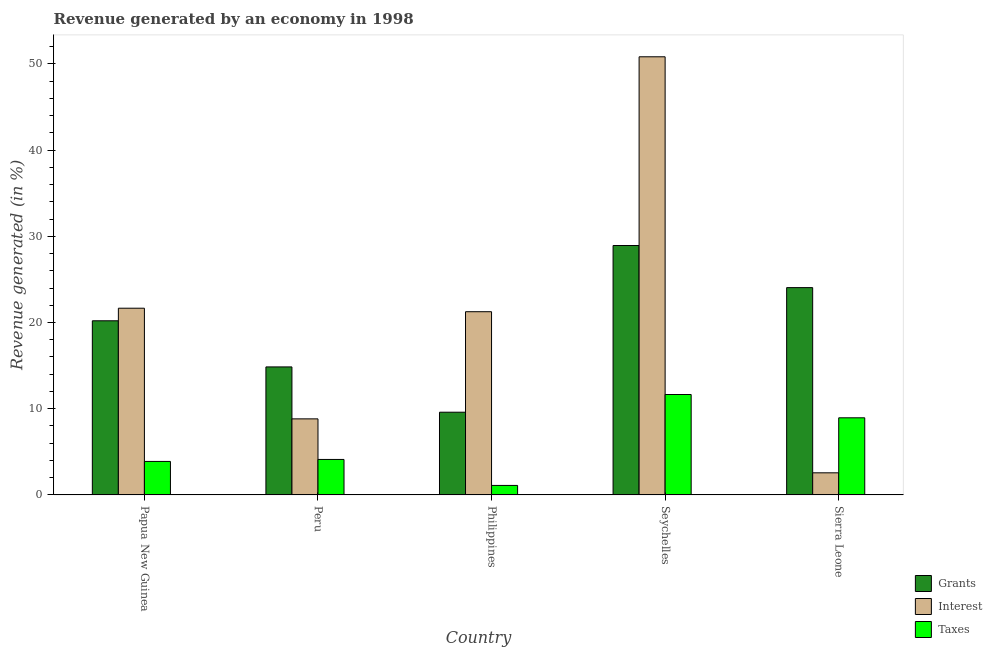How many different coloured bars are there?
Provide a short and direct response. 3. How many bars are there on the 1st tick from the right?
Provide a short and direct response. 3. What is the label of the 3rd group of bars from the left?
Provide a succinct answer. Philippines. What is the percentage of revenue generated by interest in Papua New Guinea?
Keep it short and to the point. 21.66. Across all countries, what is the maximum percentage of revenue generated by grants?
Offer a terse response. 28.93. Across all countries, what is the minimum percentage of revenue generated by taxes?
Your answer should be very brief. 1.1. In which country was the percentage of revenue generated by grants maximum?
Offer a terse response. Seychelles. What is the total percentage of revenue generated by taxes in the graph?
Offer a terse response. 29.7. What is the difference between the percentage of revenue generated by interest in Papua New Guinea and that in Seychelles?
Keep it short and to the point. -29.16. What is the difference between the percentage of revenue generated by interest in Peru and the percentage of revenue generated by grants in Philippines?
Offer a terse response. -0.77. What is the average percentage of revenue generated by interest per country?
Make the answer very short. 21.02. What is the difference between the percentage of revenue generated by interest and percentage of revenue generated by grants in Philippines?
Your answer should be very brief. 11.66. What is the ratio of the percentage of revenue generated by taxes in Philippines to that in Seychelles?
Your response must be concise. 0.09. What is the difference between the highest and the second highest percentage of revenue generated by grants?
Your response must be concise. 4.88. What is the difference between the highest and the lowest percentage of revenue generated by grants?
Provide a succinct answer. 19.33. What does the 3rd bar from the left in Seychelles represents?
Offer a very short reply. Taxes. What does the 3rd bar from the right in Seychelles represents?
Offer a very short reply. Grants. How many bars are there?
Make the answer very short. 15. How many countries are there in the graph?
Offer a terse response. 5. Does the graph contain any zero values?
Give a very brief answer. No. Does the graph contain grids?
Give a very brief answer. No. How many legend labels are there?
Ensure brevity in your answer.  3. What is the title of the graph?
Your answer should be compact. Revenue generated by an economy in 1998. Does "Ages 50+" appear as one of the legend labels in the graph?
Ensure brevity in your answer.  No. What is the label or title of the X-axis?
Offer a very short reply. Country. What is the label or title of the Y-axis?
Ensure brevity in your answer.  Revenue generated (in %). What is the Revenue generated (in %) of Grants in Papua New Guinea?
Provide a short and direct response. 20.2. What is the Revenue generated (in %) in Interest in Papua New Guinea?
Your response must be concise. 21.66. What is the Revenue generated (in %) of Taxes in Papua New Guinea?
Your answer should be compact. 3.89. What is the Revenue generated (in %) in Grants in Peru?
Offer a terse response. 14.85. What is the Revenue generated (in %) in Interest in Peru?
Make the answer very short. 8.82. What is the Revenue generated (in %) of Taxes in Peru?
Your response must be concise. 4.12. What is the Revenue generated (in %) of Grants in Philippines?
Give a very brief answer. 9.59. What is the Revenue generated (in %) of Interest in Philippines?
Give a very brief answer. 21.25. What is the Revenue generated (in %) of Taxes in Philippines?
Offer a terse response. 1.1. What is the Revenue generated (in %) in Grants in Seychelles?
Offer a terse response. 28.93. What is the Revenue generated (in %) in Interest in Seychelles?
Your answer should be compact. 50.82. What is the Revenue generated (in %) in Taxes in Seychelles?
Ensure brevity in your answer.  11.65. What is the Revenue generated (in %) in Grants in Sierra Leone?
Ensure brevity in your answer.  24.05. What is the Revenue generated (in %) in Interest in Sierra Leone?
Provide a succinct answer. 2.56. What is the Revenue generated (in %) of Taxes in Sierra Leone?
Your answer should be very brief. 8.95. Across all countries, what is the maximum Revenue generated (in %) in Grants?
Give a very brief answer. 28.93. Across all countries, what is the maximum Revenue generated (in %) in Interest?
Offer a terse response. 50.82. Across all countries, what is the maximum Revenue generated (in %) in Taxes?
Offer a terse response. 11.65. Across all countries, what is the minimum Revenue generated (in %) of Grants?
Keep it short and to the point. 9.59. Across all countries, what is the minimum Revenue generated (in %) of Interest?
Keep it short and to the point. 2.56. Across all countries, what is the minimum Revenue generated (in %) of Taxes?
Provide a succinct answer. 1.1. What is the total Revenue generated (in %) in Grants in the graph?
Your answer should be very brief. 97.62. What is the total Revenue generated (in %) of Interest in the graph?
Provide a short and direct response. 105.11. What is the total Revenue generated (in %) of Taxes in the graph?
Ensure brevity in your answer.  29.7. What is the difference between the Revenue generated (in %) of Grants in Papua New Guinea and that in Peru?
Your answer should be very brief. 5.35. What is the difference between the Revenue generated (in %) of Interest in Papua New Guinea and that in Peru?
Offer a very short reply. 12.83. What is the difference between the Revenue generated (in %) of Taxes in Papua New Guinea and that in Peru?
Provide a short and direct response. -0.23. What is the difference between the Revenue generated (in %) in Grants in Papua New Guinea and that in Philippines?
Ensure brevity in your answer.  10.6. What is the difference between the Revenue generated (in %) in Interest in Papua New Guinea and that in Philippines?
Give a very brief answer. 0.41. What is the difference between the Revenue generated (in %) in Taxes in Papua New Guinea and that in Philippines?
Keep it short and to the point. 2.78. What is the difference between the Revenue generated (in %) of Grants in Papua New Guinea and that in Seychelles?
Offer a terse response. -8.73. What is the difference between the Revenue generated (in %) of Interest in Papua New Guinea and that in Seychelles?
Give a very brief answer. -29.16. What is the difference between the Revenue generated (in %) in Taxes in Papua New Guinea and that in Seychelles?
Offer a terse response. -7.76. What is the difference between the Revenue generated (in %) of Grants in Papua New Guinea and that in Sierra Leone?
Your answer should be compact. -3.85. What is the difference between the Revenue generated (in %) in Interest in Papua New Guinea and that in Sierra Leone?
Keep it short and to the point. 19.09. What is the difference between the Revenue generated (in %) of Taxes in Papua New Guinea and that in Sierra Leone?
Offer a very short reply. -5.06. What is the difference between the Revenue generated (in %) in Grants in Peru and that in Philippines?
Offer a very short reply. 5.25. What is the difference between the Revenue generated (in %) in Interest in Peru and that in Philippines?
Keep it short and to the point. -12.43. What is the difference between the Revenue generated (in %) of Taxes in Peru and that in Philippines?
Provide a succinct answer. 3.01. What is the difference between the Revenue generated (in %) in Grants in Peru and that in Seychelles?
Provide a succinct answer. -14.08. What is the difference between the Revenue generated (in %) of Interest in Peru and that in Seychelles?
Your answer should be very brief. -42. What is the difference between the Revenue generated (in %) in Taxes in Peru and that in Seychelles?
Give a very brief answer. -7.53. What is the difference between the Revenue generated (in %) in Grants in Peru and that in Sierra Leone?
Your answer should be very brief. -9.2. What is the difference between the Revenue generated (in %) in Interest in Peru and that in Sierra Leone?
Your response must be concise. 6.26. What is the difference between the Revenue generated (in %) in Taxes in Peru and that in Sierra Leone?
Ensure brevity in your answer.  -4.83. What is the difference between the Revenue generated (in %) in Grants in Philippines and that in Seychelles?
Offer a terse response. -19.33. What is the difference between the Revenue generated (in %) of Interest in Philippines and that in Seychelles?
Your answer should be very brief. -29.57. What is the difference between the Revenue generated (in %) of Taxes in Philippines and that in Seychelles?
Keep it short and to the point. -10.54. What is the difference between the Revenue generated (in %) of Grants in Philippines and that in Sierra Leone?
Offer a terse response. -14.45. What is the difference between the Revenue generated (in %) in Interest in Philippines and that in Sierra Leone?
Offer a terse response. 18.69. What is the difference between the Revenue generated (in %) in Taxes in Philippines and that in Sierra Leone?
Provide a succinct answer. -7.84. What is the difference between the Revenue generated (in %) of Grants in Seychelles and that in Sierra Leone?
Offer a very short reply. 4.88. What is the difference between the Revenue generated (in %) of Interest in Seychelles and that in Sierra Leone?
Your answer should be very brief. 48.26. What is the difference between the Revenue generated (in %) in Taxes in Seychelles and that in Sierra Leone?
Your answer should be compact. 2.7. What is the difference between the Revenue generated (in %) of Grants in Papua New Guinea and the Revenue generated (in %) of Interest in Peru?
Ensure brevity in your answer.  11.37. What is the difference between the Revenue generated (in %) of Grants in Papua New Guinea and the Revenue generated (in %) of Taxes in Peru?
Your answer should be very brief. 16.08. What is the difference between the Revenue generated (in %) in Interest in Papua New Guinea and the Revenue generated (in %) in Taxes in Peru?
Ensure brevity in your answer.  17.54. What is the difference between the Revenue generated (in %) in Grants in Papua New Guinea and the Revenue generated (in %) in Interest in Philippines?
Provide a succinct answer. -1.05. What is the difference between the Revenue generated (in %) in Grants in Papua New Guinea and the Revenue generated (in %) in Taxes in Philippines?
Offer a terse response. 19.1. What is the difference between the Revenue generated (in %) of Interest in Papua New Guinea and the Revenue generated (in %) of Taxes in Philippines?
Provide a short and direct response. 20.55. What is the difference between the Revenue generated (in %) of Grants in Papua New Guinea and the Revenue generated (in %) of Interest in Seychelles?
Your answer should be very brief. -30.62. What is the difference between the Revenue generated (in %) in Grants in Papua New Guinea and the Revenue generated (in %) in Taxes in Seychelles?
Keep it short and to the point. 8.55. What is the difference between the Revenue generated (in %) of Interest in Papua New Guinea and the Revenue generated (in %) of Taxes in Seychelles?
Your answer should be very brief. 10.01. What is the difference between the Revenue generated (in %) of Grants in Papua New Guinea and the Revenue generated (in %) of Interest in Sierra Leone?
Provide a short and direct response. 17.63. What is the difference between the Revenue generated (in %) of Grants in Papua New Guinea and the Revenue generated (in %) of Taxes in Sierra Leone?
Offer a very short reply. 11.25. What is the difference between the Revenue generated (in %) in Interest in Papua New Guinea and the Revenue generated (in %) in Taxes in Sierra Leone?
Ensure brevity in your answer.  12.71. What is the difference between the Revenue generated (in %) in Grants in Peru and the Revenue generated (in %) in Interest in Philippines?
Your answer should be very brief. -6.4. What is the difference between the Revenue generated (in %) in Grants in Peru and the Revenue generated (in %) in Taxes in Philippines?
Your answer should be very brief. 13.75. What is the difference between the Revenue generated (in %) of Interest in Peru and the Revenue generated (in %) of Taxes in Philippines?
Your answer should be compact. 7.72. What is the difference between the Revenue generated (in %) in Grants in Peru and the Revenue generated (in %) in Interest in Seychelles?
Make the answer very short. -35.97. What is the difference between the Revenue generated (in %) in Grants in Peru and the Revenue generated (in %) in Taxes in Seychelles?
Your response must be concise. 3.2. What is the difference between the Revenue generated (in %) in Interest in Peru and the Revenue generated (in %) in Taxes in Seychelles?
Your answer should be compact. -2.82. What is the difference between the Revenue generated (in %) of Grants in Peru and the Revenue generated (in %) of Interest in Sierra Leone?
Your answer should be very brief. 12.28. What is the difference between the Revenue generated (in %) in Grants in Peru and the Revenue generated (in %) in Taxes in Sierra Leone?
Offer a very short reply. 5.9. What is the difference between the Revenue generated (in %) of Interest in Peru and the Revenue generated (in %) of Taxes in Sierra Leone?
Your response must be concise. -0.12. What is the difference between the Revenue generated (in %) in Grants in Philippines and the Revenue generated (in %) in Interest in Seychelles?
Provide a short and direct response. -41.22. What is the difference between the Revenue generated (in %) of Grants in Philippines and the Revenue generated (in %) of Taxes in Seychelles?
Your answer should be compact. -2.05. What is the difference between the Revenue generated (in %) in Interest in Philippines and the Revenue generated (in %) in Taxes in Seychelles?
Your response must be concise. 9.6. What is the difference between the Revenue generated (in %) of Grants in Philippines and the Revenue generated (in %) of Interest in Sierra Leone?
Your answer should be very brief. 7.03. What is the difference between the Revenue generated (in %) in Grants in Philippines and the Revenue generated (in %) in Taxes in Sierra Leone?
Your answer should be very brief. 0.65. What is the difference between the Revenue generated (in %) in Interest in Philippines and the Revenue generated (in %) in Taxes in Sierra Leone?
Provide a succinct answer. 12.3. What is the difference between the Revenue generated (in %) in Grants in Seychelles and the Revenue generated (in %) in Interest in Sierra Leone?
Make the answer very short. 26.37. What is the difference between the Revenue generated (in %) of Grants in Seychelles and the Revenue generated (in %) of Taxes in Sierra Leone?
Your answer should be compact. 19.98. What is the difference between the Revenue generated (in %) of Interest in Seychelles and the Revenue generated (in %) of Taxes in Sierra Leone?
Your answer should be very brief. 41.87. What is the average Revenue generated (in %) in Grants per country?
Give a very brief answer. 19.52. What is the average Revenue generated (in %) in Interest per country?
Your answer should be compact. 21.02. What is the average Revenue generated (in %) of Taxes per country?
Your response must be concise. 5.94. What is the difference between the Revenue generated (in %) in Grants and Revenue generated (in %) in Interest in Papua New Guinea?
Make the answer very short. -1.46. What is the difference between the Revenue generated (in %) in Grants and Revenue generated (in %) in Taxes in Papua New Guinea?
Your response must be concise. 16.31. What is the difference between the Revenue generated (in %) in Interest and Revenue generated (in %) in Taxes in Papua New Guinea?
Your answer should be very brief. 17.77. What is the difference between the Revenue generated (in %) in Grants and Revenue generated (in %) in Interest in Peru?
Keep it short and to the point. 6.02. What is the difference between the Revenue generated (in %) of Grants and Revenue generated (in %) of Taxes in Peru?
Offer a very short reply. 10.73. What is the difference between the Revenue generated (in %) in Interest and Revenue generated (in %) in Taxes in Peru?
Provide a short and direct response. 4.71. What is the difference between the Revenue generated (in %) in Grants and Revenue generated (in %) in Interest in Philippines?
Your answer should be compact. -11.66. What is the difference between the Revenue generated (in %) in Grants and Revenue generated (in %) in Taxes in Philippines?
Ensure brevity in your answer.  8.49. What is the difference between the Revenue generated (in %) of Interest and Revenue generated (in %) of Taxes in Philippines?
Offer a very short reply. 20.15. What is the difference between the Revenue generated (in %) in Grants and Revenue generated (in %) in Interest in Seychelles?
Your response must be concise. -21.89. What is the difference between the Revenue generated (in %) in Grants and Revenue generated (in %) in Taxes in Seychelles?
Offer a terse response. 17.28. What is the difference between the Revenue generated (in %) of Interest and Revenue generated (in %) of Taxes in Seychelles?
Make the answer very short. 39.17. What is the difference between the Revenue generated (in %) in Grants and Revenue generated (in %) in Interest in Sierra Leone?
Keep it short and to the point. 21.48. What is the difference between the Revenue generated (in %) of Grants and Revenue generated (in %) of Taxes in Sierra Leone?
Keep it short and to the point. 15.1. What is the difference between the Revenue generated (in %) in Interest and Revenue generated (in %) in Taxes in Sierra Leone?
Keep it short and to the point. -6.38. What is the ratio of the Revenue generated (in %) of Grants in Papua New Guinea to that in Peru?
Your answer should be compact. 1.36. What is the ratio of the Revenue generated (in %) of Interest in Papua New Guinea to that in Peru?
Give a very brief answer. 2.45. What is the ratio of the Revenue generated (in %) in Taxes in Papua New Guinea to that in Peru?
Your answer should be very brief. 0.94. What is the ratio of the Revenue generated (in %) of Grants in Papua New Guinea to that in Philippines?
Give a very brief answer. 2.11. What is the ratio of the Revenue generated (in %) of Interest in Papua New Guinea to that in Philippines?
Offer a very short reply. 1.02. What is the ratio of the Revenue generated (in %) in Taxes in Papua New Guinea to that in Philippines?
Your response must be concise. 3.52. What is the ratio of the Revenue generated (in %) of Grants in Papua New Guinea to that in Seychelles?
Your answer should be compact. 0.7. What is the ratio of the Revenue generated (in %) of Interest in Papua New Guinea to that in Seychelles?
Provide a short and direct response. 0.43. What is the ratio of the Revenue generated (in %) of Taxes in Papua New Guinea to that in Seychelles?
Offer a terse response. 0.33. What is the ratio of the Revenue generated (in %) of Grants in Papua New Guinea to that in Sierra Leone?
Give a very brief answer. 0.84. What is the ratio of the Revenue generated (in %) of Interest in Papua New Guinea to that in Sierra Leone?
Keep it short and to the point. 8.45. What is the ratio of the Revenue generated (in %) of Taxes in Papua New Guinea to that in Sierra Leone?
Your answer should be very brief. 0.43. What is the ratio of the Revenue generated (in %) of Grants in Peru to that in Philippines?
Offer a terse response. 1.55. What is the ratio of the Revenue generated (in %) of Interest in Peru to that in Philippines?
Keep it short and to the point. 0.42. What is the ratio of the Revenue generated (in %) in Taxes in Peru to that in Philippines?
Keep it short and to the point. 3.73. What is the ratio of the Revenue generated (in %) of Grants in Peru to that in Seychelles?
Offer a very short reply. 0.51. What is the ratio of the Revenue generated (in %) of Interest in Peru to that in Seychelles?
Give a very brief answer. 0.17. What is the ratio of the Revenue generated (in %) of Taxes in Peru to that in Seychelles?
Ensure brevity in your answer.  0.35. What is the ratio of the Revenue generated (in %) of Grants in Peru to that in Sierra Leone?
Provide a short and direct response. 0.62. What is the ratio of the Revenue generated (in %) of Interest in Peru to that in Sierra Leone?
Give a very brief answer. 3.44. What is the ratio of the Revenue generated (in %) in Taxes in Peru to that in Sierra Leone?
Your response must be concise. 0.46. What is the ratio of the Revenue generated (in %) of Grants in Philippines to that in Seychelles?
Provide a short and direct response. 0.33. What is the ratio of the Revenue generated (in %) in Interest in Philippines to that in Seychelles?
Ensure brevity in your answer.  0.42. What is the ratio of the Revenue generated (in %) in Taxes in Philippines to that in Seychelles?
Provide a short and direct response. 0.09. What is the ratio of the Revenue generated (in %) in Grants in Philippines to that in Sierra Leone?
Keep it short and to the point. 0.4. What is the ratio of the Revenue generated (in %) of Interest in Philippines to that in Sierra Leone?
Offer a terse response. 8.29. What is the ratio of the Revenue generated (in %) of Taxes in Philippines to that in Sierra Leone?
Your response must be concise. 0.12. What is the ratio of the Revenue generated (in %) of Grants in Seychelles to that in Sierra Leone?
Offer a very short reply. 1.2. What is the ratio of the Revenue generated (in %) in Interest in Seychelles to that in Sierra Leone?
Make the answer very short. 19.82. What is the ratio of the Revenue generated (in %) of Taxes in Seychelles to that in Sierra Leone?
Ensure brevity in your answer.  1.3. What is the difference between the highest and the second highest Revenue generated (in %) of Grants?
Your answer should be compact. 4.88. What is the difference between the highest and the second highest Revenue generated (in %) in Interest?
Make the answer very short. 29.16. What is the difference between the highest and the second highest Revenue generated (in %) in Taxes?
Your answer should be very brief. 2.7. What is the difference between the highest and the lowest Revenue generated (in %) of Grants?
Offer a terse response. 19.33. What is the difference between the highest and the lowest Revenue generated (in %) of Interest?
Provide a short and direct response. 48.26. What is the difference between the highest and the lowest Revenue generated (in %) in Taxes?
Provide a short and direct response. 10.54. 